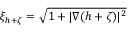Convert formula to latex. <formula><loc_0><loc_0><loc_500><loc_500>\xi _ { h + \zeta } = \sqrt { 1 + | \nabla ( h + \zeta ) | ^ { 2 } }</formula> 